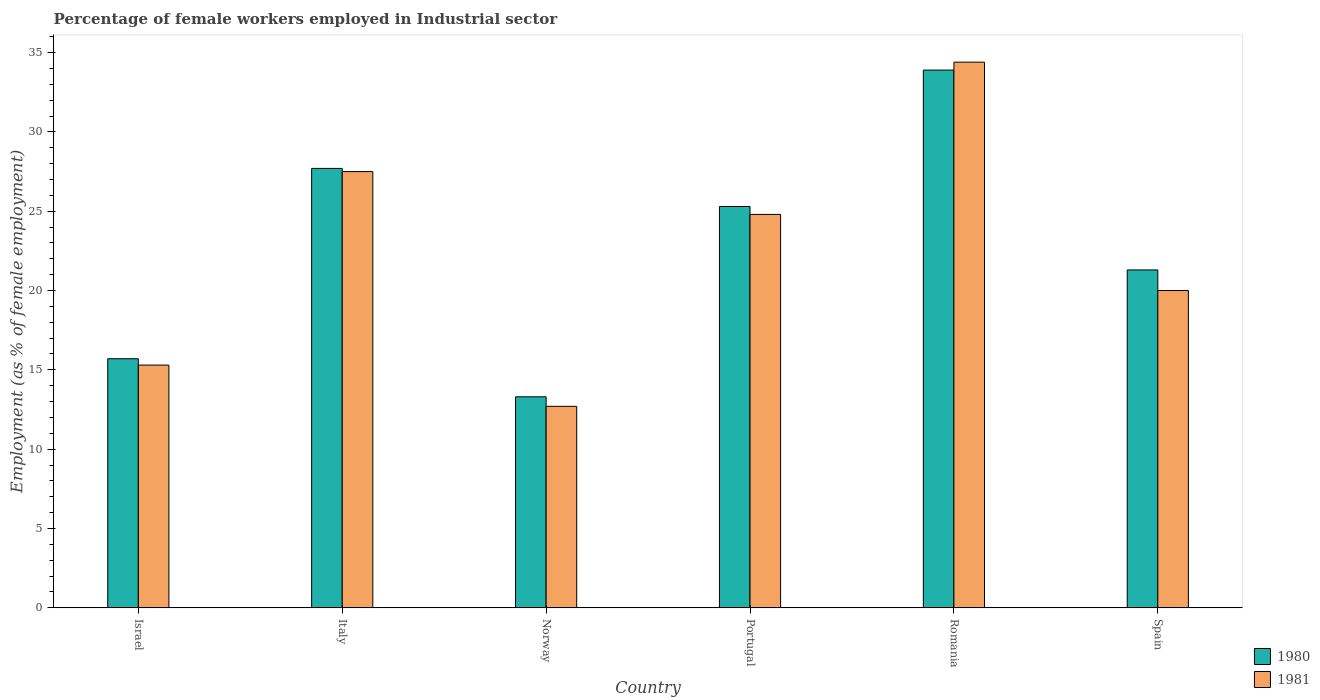How many groups of bars are there?
Give a very brief answer. 6. Are the number of bars per tick equal to the number of legend labels?
Your response must be concise. Yes. Are the number of bars on each tick of the X-axis equal?
Make the answer very short. Yes. How many bars are there on the 1st tick from the left?
Your response must be concise. 2. How many bars are there on the 3rd tick from the right?
Make the answer very short. 2. What is the label of the 3rd group of bars from the left?
Offer a very short reply. Norway. In how many cases, is the number of bars for a given country not equal to the number of legend labels?
Offer a terse response. 0. What is the percentage of females employed in Industrial sector in 1981 in Israel?
Provide a succinct answer. 15.3. Across all countries, what is the maximum percentage of females employed in Industrial sector in 1980?
Keep it short and to the point. 33.9. Across all countries, what is the minimum percentage of females employed in Industrial sector in 1981?
Offer a very short reply. 12.7. In which country was the percentage of females employed in Industrial sector in 1981 maximum?
Your answer should be compact. Romania. In which country was the percentage of females employed in Industrial sector in 1980 minimum?
Your answer should be compact. Norway. What is the total percentage of females employed in Industrial sector in 1980 in the graph?
Offer a terse response. 137.2. What is the difference between the percentage of females employed in Industrial sector in 1981 in Norway and that in Spain?
Your answer should be very brief. -7.3. What is the difference between the percentage of females employed in Industrial sector in 1981 in Romania and the percentage of females employed in Industrial sector in 1980 in Israel?
Ensure brevity in your answer.  18.7. What is the average percentage of females employed in Industrial sector in 1981 per country?
Provide a succinct answer. 22.45. What is the difference between the percentage of females employed in Industrial sector of/in 1980 and percentage of females employed in Industrial sector of/in 1981 in Romania?
Make the answer very short. -0.5. What is the ratio of the percentage of females employed in Industrial sector in 1981 in Israel to that in Norway?
Make the answer very short. 1.2. What is the difference between the highest and the second highest percentage of females employed in Industrial sector in 1980?
Your answer should be compact. 6.2. What is the difference between the highest and the lowest percentage of females employed in Industrial sector in 1980?
Your response must be concise. 20.6. In how many countries, is the percentage of females employed in Industrial sector in 1981 greater than the average percentage of females employed in Industrial sector in 1981 taken over all countries?
Your response must be concise. 3. What does the 1st bar from the left in Italy represents?
Make the answer very short. 1980. What does the 1st bar from the right in Romania represents?
Offer a terse response. 1981. How many bars are there?
Offer a very short reply. 12. Does the graph contain grids?
Offer a terse response. No. Where does the legend appear in the graph?
Give a very brief answer. Bottom right. How are the legend labels stacked?
Give a very brief answer. Vertical. What is the title of the graph?
Offer a very short reply. Percentage of female workers employed in Industrial sector. What is the label or title of the Y-axis?
Keep it short and to the point. Employment (as % of female employment). What is the Employment (as % of female employment) of 1980 in Israel?
Your answer should be compact. 15.7. What is the Employment (as % of female employment) of 1981 in Israel?
Provide a short and direct response. 15.3. What is the Employment (as % of female employment) in 1980 in Italy?
Your response must be concise. 27.7. What is the Employment (as % of female employment) of 1981 in Italy?
Your answer should be very brief. 27.5. What is the Employment (as % of female employment) of 1980 in Norway?
Your answer should be very brief. 13.3. What is the Employment (as % of female employment) of 1981 in Norway?
Your answer should be compact. 12.7. What is the Employment (as % of female employment) of 1980 in Portugal?
Offer a terse response. 25.3. What is the Employment (as % of female employment) of 1981 in Portugal?
Provide a succinct answer. 24.8. What is the Employment (as % of female employment) of 1980 in Romania?
Ensure brevity in your answer.  33.9. What is the Employment (as % of female employment) of 1981 in Romania?
Provide a short and direct response. 34.4. What is the Employment (as % of female employment) in 1980 in Spain?
Provide a short and direct response. 21.3. Across all countries, what is the maximum Employment (as % of female employment) in 1980?
Offer a very short reply. 33.9. Across all countries, what is the maximum Employment (as % of female employment) in 1981?
Ensure brevity in your answer.  34.4. Across all countries, what is the minimum Employment (as % of female employment) of 1980?
Keep it short and to the point. 13.3. Across all countries, what is the minimum Employment (as % of female employment) in 1981?
Ensure brevity in your answer.  12.7. What is the total Employment (as % of female employment) in 1980 in the graph?
Your response must be concise. 137.2. What is the total Employment (as % of female employment) of 1981 in the graph?
Give a very brief answer. 134.7. What is the difference between the Employment (as % of female employment) of 1980 in Israel and that in Italy?
Ensure brevity in your answer.  -12. What is the difference between the Employment (as % of female employment) in 1981 in Israel and that in Italy?
Offer a terse response. -12.2. What is the difference between the Employment (as % of female employment) in 1980 in Israel and that in Norway?
Your answer should be compact. 2.4. What is the difference between the Employment (as % of female employment) in 1981 in Israel and that in Norway?
Your response must be concise. 2.6. What is the difference between the Employment (as % of female employment) of 1980 in Israel and that in Portugal?
Provide a short and direct response. -9.6. What is the difference between the Employment (as % of female employment) in 1981 in Israel and that in Portugal?
Offer a terse response. -9.5. What is the difference between the Employment (as % of female employment) in 1980 in Israel and that in Romania?
Provide a short and direct response. -18.2. What is the difference between the Employment (as % of female employment) of 1981 in Israel and that in Romania?
Your answer should be compact. -19.1. What is the difference between the Employment (as % of female employment) in 1981 in Israel and that in Spain?
Provide a short and direct response. -4.7. What is the difference between the Employment (as % of female employment) in 1980 in Italy and that in Norway?
Make the answer very short. 14.4. What is the difference between the Employment (as % of female employment) in 1980 in Italy and that in Portugal?
Make the answer very short. 2.4. What is the difference between the Employment (as % of female employment) of 1981 in Italy and that in Romania?
Provide a short and direct response. -6.9. What is the difference between the Employment (as % of female employment) of 1980 in Italy and that in Spain?
Your response must be concise. 6.4. What is the difference between the Employment (as % of female employment) in 1981 in Italy and that in Spain?
Your response must be concise. 7.5. What is the difference between the Employment (as % of female employment) of 1981 in Norway and that in Portugal?
Provide a short and direct response. -12.1. What is the difference between the Employment (as % of female employment) in 1980 in Norway and that in Romania?
Keep it short and to the point. -20.6. What is the difference between the Employment (as % of female employment) of 1981 in Norway and that in Romania?
Your answer should be compact. -21.7. What is the difference between the Employment (as % of female employment) of 1980 in Norway and that in Spain?
Provide a short and direct response. -8. What is the difference between the Employment (as % of female employment) of 1981 in Norway and that in Spain?
Ensure brevity in your answer.  -7.3. What is the difference between the Employment (as % of female employment) in 1981 in Portugal and that in Romania?
Provide a short and direct response. -9.6. What is the difference between the Employment (as % of female employment) of 1980 in Portugal and that in Spain?
Ensure brevity in your answer.  4. What is the difference between the Employment (as % of female employment) in 1981 in Portugal and that in Spain?
Your answer should be very brief. 4.8. What is the difference between the Employment (as % of female employment) in 1980 in Romania and that in Spain?
Make the answer very short. 12.6. What is the difference between the Employment (as % of female employment) of 1981 in Romania and that in Spain?
Ensure brevity in your answer.  14.4. What is the difference between the Employment (as % of female employment) of 1980 in Israel and the Employment (as % of female employment) of 1981 in Italy?
Provide a succinct answer. -11.8. What is the difference between the Employment (as % of female employment) of 1980 in Israel and the Employment (as % of female employment) of 1981 in Norway?
Offer a very short reply. 3. What is the difference between the Employment (as % of female employment) of 1980 in Israel and the Employment (as % of female employment) of 1981 in Portugal?
Your answer should be compact. -9.1. What is the difference between the Employment (as % of female employment) in 1980 in Israel and the Employment (as % of female employment) in 1981 in Romania?
Make the answer very short. -18.7. What is the difference between the Employment (as % of female employment) in 1980 in Italy and the Employment (as % of female employment) in 1981 in Norway?
Provide a short and direct response. 15. What is the difference between the Employment (as % of female employment) in 1980 in Italy and the Employment (as % of female employment) in 1981 in Portugal?
Offer a very short reply. 2.9. What is the difference between the Employment (as % of female employment) of 1980 in Italy and the Employment (as % of female employment) of 1981 in Romania?
Offer a terse response. -6.7. What is the difference between the Employment (as % of female employment) in 1980 in Italy and the Employment (as % of female employment) in 1981 in Spain?
Your response must be concise. 7.7. What is the difference between the Employment (as % of female employment) in 1980 in Norway and the Employment (as % of female employment) in 1981 in Portugal?
Give a very brief answer. -11.5. What is the difference between the Employment (as % of female employment) in 1980 in Norway and the Employment (as % of female employment) in 1981 in Romania?
Give a very brief answer. -21.1. What is the difference between the Employment (as % of female employment) in 1980 in Romania and the Employment (as % of female employment) in 1981 in Spain?
Your answer should be compact. 13.9. What is the average Employment (as % of female employment) of 1980 per country?
Provide a short and direct response. 22.87. What is the average Employment (as % of female employment) of 1981 per country?
Keep it short and to the point. 22.45. What is the difference between the Employment (as % of female employment) of 1980 and Employment (as % of female employment) of 1981 in Romania?
Offer a very short reply. -0.5. What is the difference between the Employment (as % of female employment) in 1980 and Employment (as % of female employment) in 1981 in Spain?
Your answer should be very brief. 1.3. What is the ratio of the Employment (as % of female employment) in 1980 in Israel to that in Italy?
Your answer should be compact. 0.57. What is the ratio of the Employment (as % of female employment) in 1981 in Israel to that in Italy?
Your answer should be compact. 0.56. What is the ratio of the Employment (as % of female employment) in 1980 in Israel to that in Norway?
Make the answer very short. 1.18. What is the ratio of the Employment (as % of female employment) in 1981 in Israel to that in Norway?
Keep it short and to the point. 1.2. What is the ratio of the Employment (as % of female employment) in 1980 in Israel to that in Portugal?
Your response must be concise. 0.62. What is the ratio of the Employment (as % of female employment) in 1981 in Israel to that in Portugal?
Your answer should be compact. 0.62. What is the ratio of the Employment (as % of female employment) in 1980 in Israel to that in Romania?
Offer a terse response. 0.46. What is the ratio of the Employment (as % of female employment) in 1981 in Israel to that in Romania?
Provide a succinct answer. 0.44. What is the ratio of the Employment (as % of female employment) of 1980 in Israel to that in Spain?
Offer a terse response. 0.74. What is the ratio of the Employment (as % of female employment) in 1981 in Israel to that in Spain?
Provide a succinct answer. 0.77. What is the ratio of the Employment (as % of female employment) of 1980 in Italy to that in Norway?
Make the answer very short. 2.08. What is the ratio of the Employment (as % of female employment) of 1981 in Italy to that in Norway?
Provide a short and direct response. 2.17. What is the ratio of the Employment (as % of female employment) in 1980 in Italy to that in Portugal?
Offer a very short reply. 1.09. What is the ratio of the Employment (as % of female employment) of 1981 in Italy to that in Portugal?
Ensure brevity in your answer.  1.11. What is the ratio of the Employment (as % of female employment) in 1980 in Italy to that in Romania?
Provide a short and direct response. 0.82. What is the ratio of the Employment (as % of female employment) of 1981 in Italy to that in Romania?
Ensure brevity in your answer.  0.8. What is the ratio of the Employment (as % of female employment) in 1980 in Italy to that in Spain?
Ensure brevity in your answer.  1.3. What is the ratio of the Employment (as % of female employment) in 1981 in Italy to that in Spain?
Provide a short and direct response. 1.38. What is the ratio of the Employment (as % of female employment) in 1980 in Norway to that in Portugal?
Provide a short and direct response. 0.53. What is the ratio of the Employment (as % of female employment) of 1981 in Norway to that in Portugal?
Provide a short and direct response. 0.51. What is the ratio of the Employment (as % of female employment) of 1980 in Norway to that in Romania?
Provide a succinct answer. 0.39. What is the ratio of the Employment (as % of female employment) in 1981 in Norway to that in Romania?
Ensure brevity in your answer.  0.37. What is the ratio of the Employment (as % of female employment) of 1980 in Norway to that in Spain?
Offer a terse response. 0.62. What is the ratio of the Employment (as % of female employment) of 1981 in Norway to that in Spain?
Your answer should be very brief. 0.64. What is the ratio of the Employment (as % of female employment) of 1980 in Portugal to that in Romania?
Your response must be concise. 0.75. What is the ratio of the Employment (as % of female employment) in 1981 in Portugal to that in Romania?
Provide a succinct answer. 0.72. What is the ratio of the Employment (as % of female employment) of 1980 in Portugal to that in Spain?
Provide a succinct answer. 1.19. What is the ratio of the Employment (as % of female employment) in 1981 in Portugal to that in Spain?
Provide a succinct answer. 1.24. What is the ratio of the Employment (as % of female employment) of 1980 in Romania to that in Spain?
Provide a short and direct response. 1.59. What is the ratio of the Employment (as % of female employment) of 1981 in Romania to that in Spain?
Offer a very short reply. 1.72. What is the difference between the highest and the second highest Employment (as % of female employment) in 1981?
Offer a very short reply. 6.9. What is the difference between the highest and the lowest Employment (as % of female employment) in 1980?
Your answer should be very brief. 20.6. What is the difference between the highest and the lowest Employment (as % of female employment) in 1981?
Offer a very short reply. 21.7. 